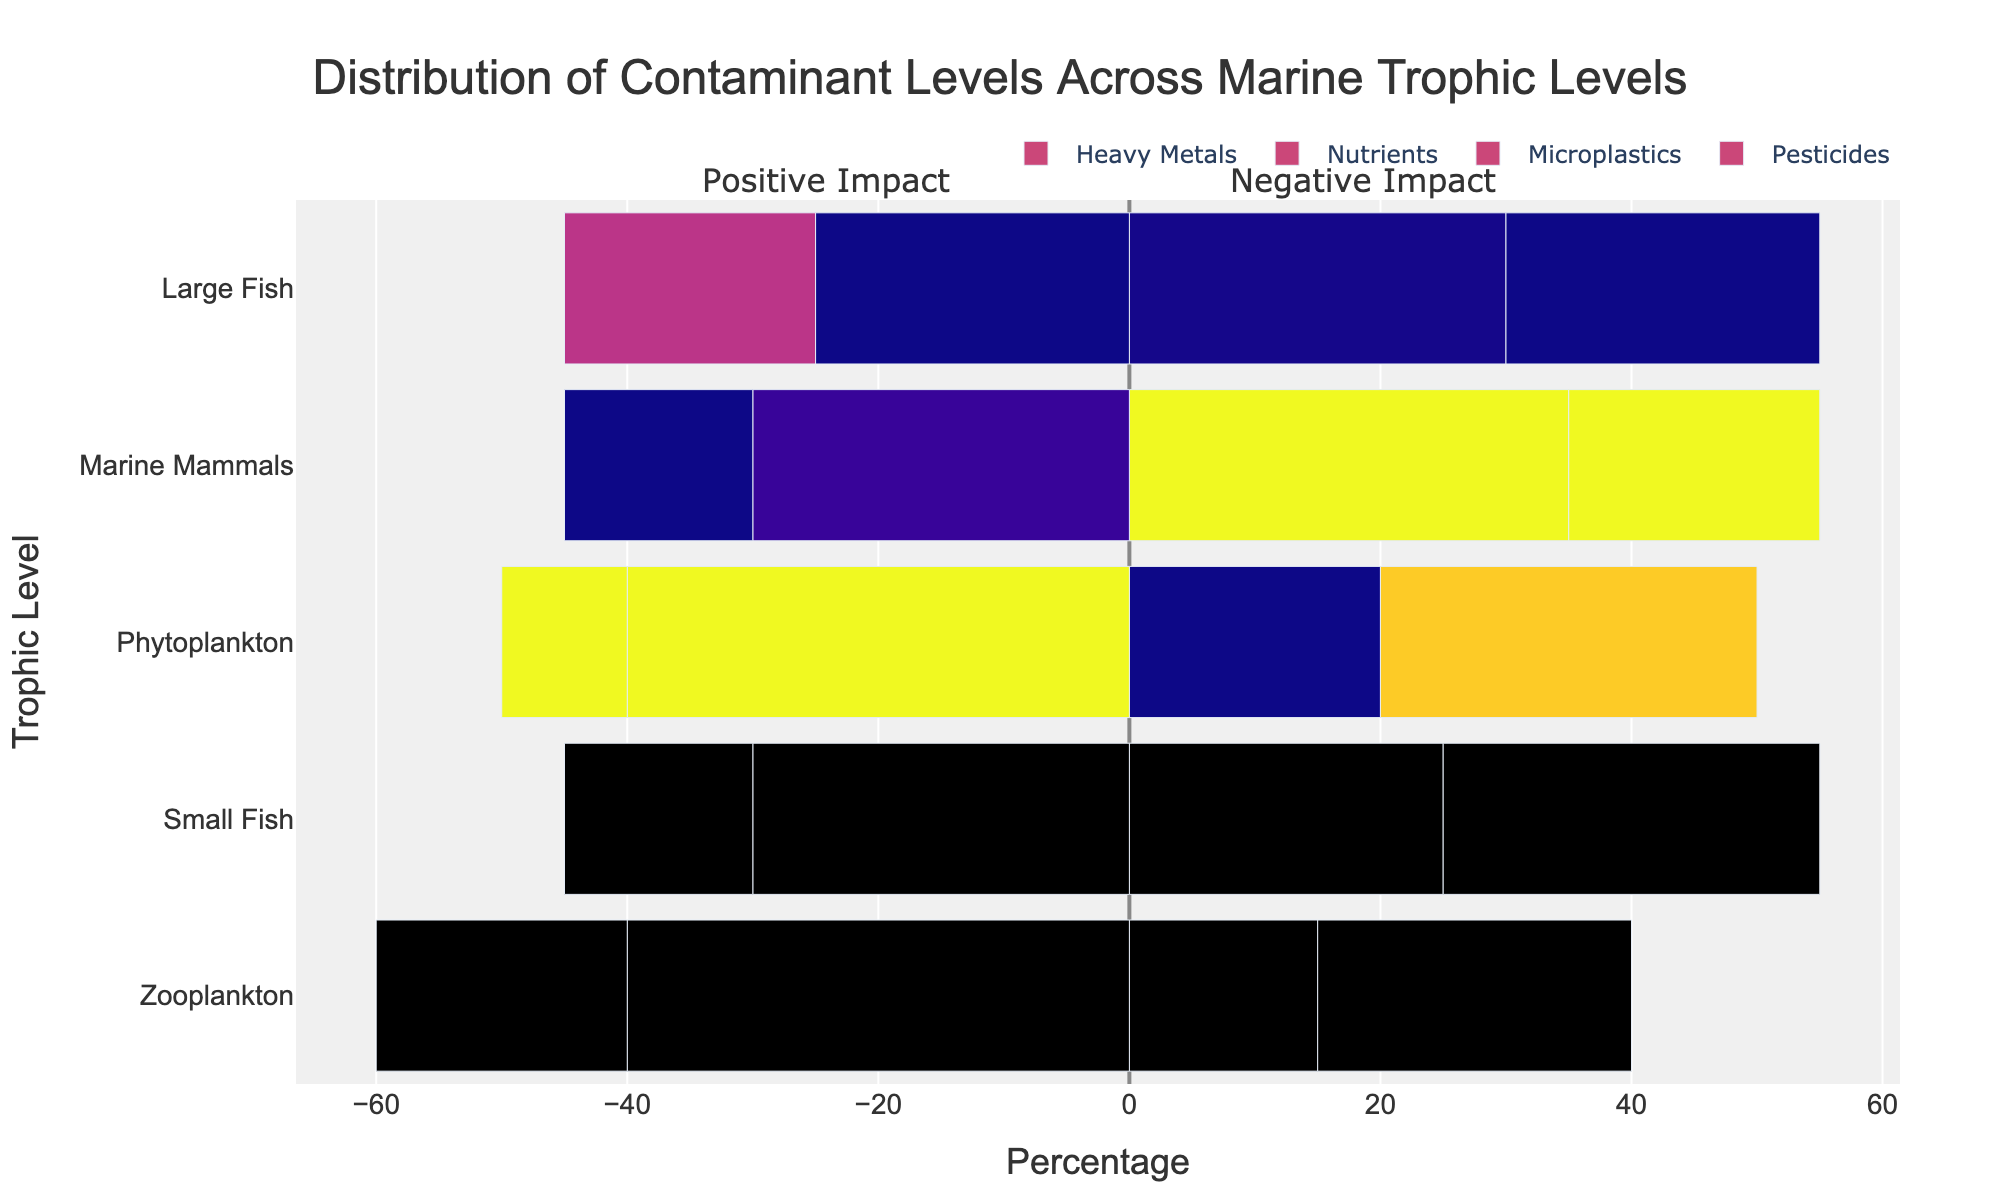Which trophic level has the highest percentage of Heavy Metals? We observe that Marine Mammals have the longest positive bar for Heavy Metals, which is at 35%. Hence, Marine Mammals have the highest percentage of Heavy Metals.
Answer: Marine Mammals Which contaminant shows equal percentage impacts on Phytoplankton both positively and negatively? Looking at the Phytoplankton data, Nutrients have a 30% positive impact and Microplastics have a 40% negative impact, but only Nutrients fits the requirement for equality with a non-zero value in both impact types.
Answer: None Which trophic level has the least negative impact of Pesticides? The length of the negative bars for Pesticides shows that Marine Mammals and Small Fish have the shortest bars, both at 15%. Therefore, both have the least negative impact of Pesticides.
Answer: Marine Mammals, Small Fish What is the total negative impact of all contaminants on Zooplankton? We sum the length of the negative bars for Zooplankton: 20% (Pesticides) + 40% (Microplastics) = 60%. Thus, the total negative impact is 60%.
Answer: 60% Which contaminant has the highest total positive impact across all trophic levels? By summing the positive percentages for each contaminant: 
  - Heavy Metals: 20 + 15 + 25 + 30 + 35 = 125%
  - Nutrients: 30 + 25 + 30 + 25 + 20 = 130%
  - The highest value is for Nutrients at 130%.
Answer: Nutrients Compare the positive impact percentage between Large Fish and Small Fish for Heavy Metals. Large Fish has a positive impact percentage of 30% for Heavy Metals, while Small Fish has 25%. Hence, Large Fish has a larger positive impact for Heavy Metals.
Answer: Large Fish Which contaminant has a larger negative impact on Phytoplankton: Pesticides or Microplastics? Pesticides have a negative impact of 10% on Phytoplankton, while Microplastics have 40%. Therefore, Microplastics have a larger negative impact on Phytoplankton.
Answer: Microplastics Which trophic level has the smallest range between its highest positive and highest negative impact? By calculating the ranges for each trophic level:
  - Phytoplankton: Range = max(30, 40) - min(10, 10) = 40 - 10 = 30%
  - Zooplankton: Range = max(25, 40) - min(15, 20) = 40 - 15 = 25%
  - Small Fish: Range = max(30, 30) - min(15, 15) = 30 - 15 = 15%
  - Large Fish: Range = max(30, 30) - min(20, 20) = 30 - 20 = 10%
  - Marine Mammals: Range = max(35, 30) - min(15, 15) = 35 - 15 = 20%
  The smallest range is 10% for Large Fish.
Answer: Large Fish 